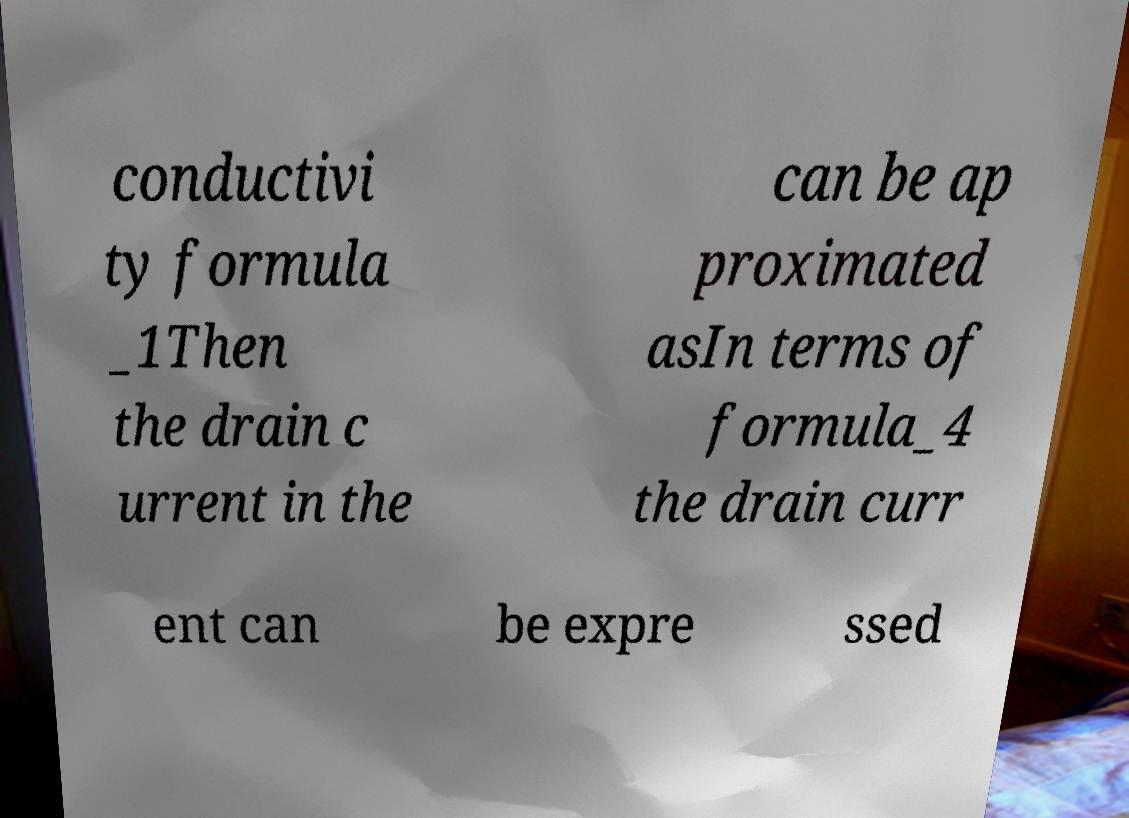Can you accurately transcribe the text from the provided image for me? conductivi ty formula _1Then the drain c urrent in the can be ap proximated asIn terms of formula_4 the drain curr ent can be expre ssed 